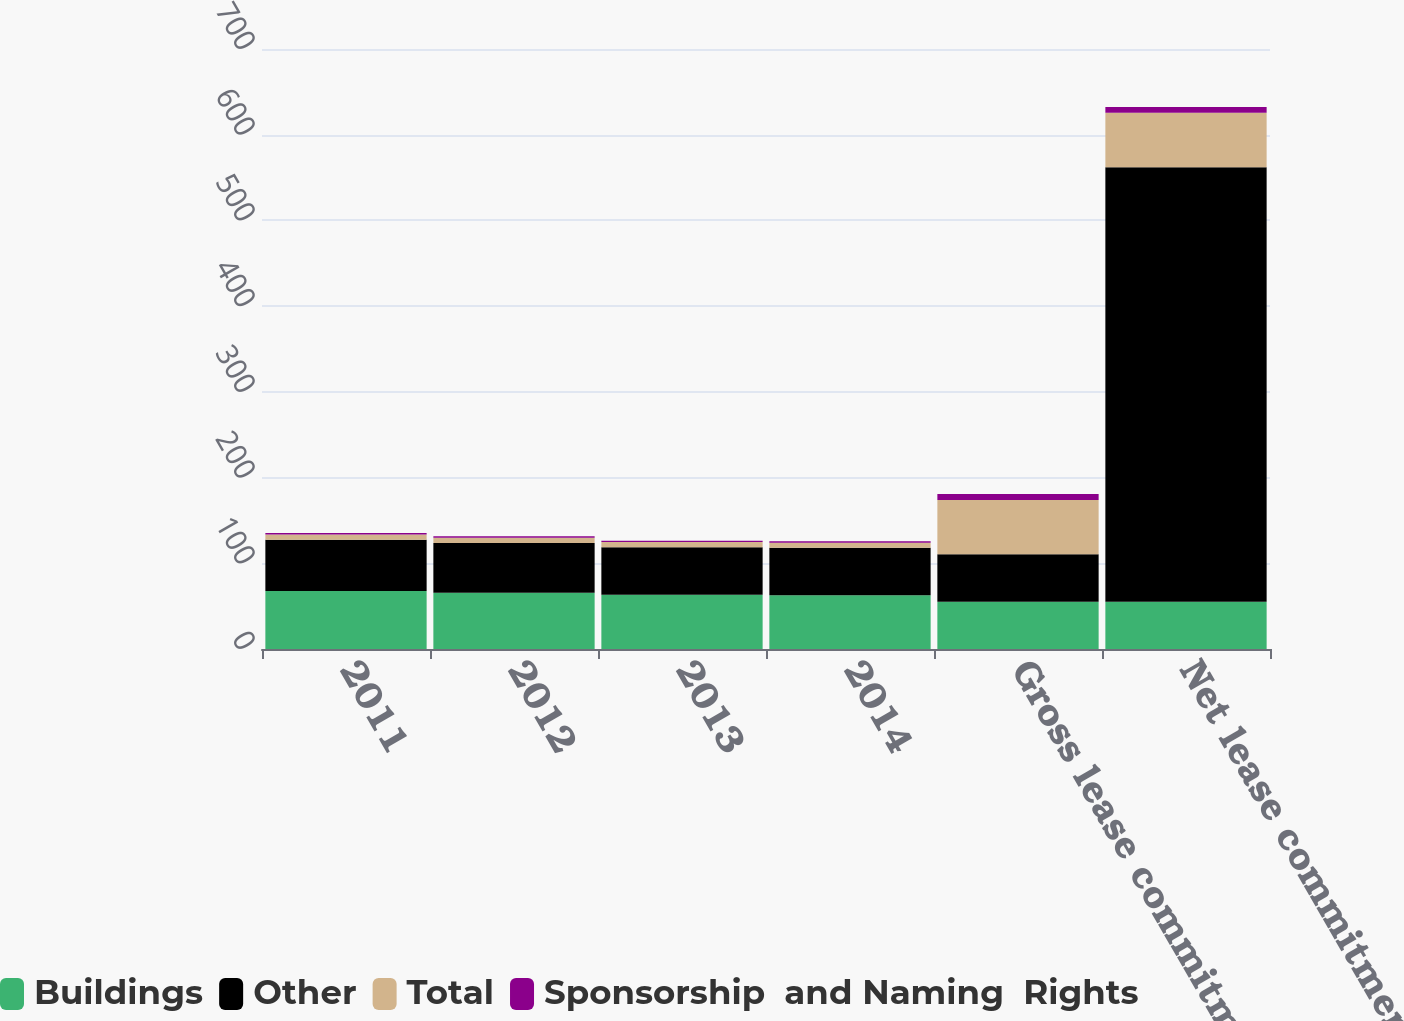Convert chart to OTSL. <chart><loc_0><loc_0><loc_500><loc_500><stacked_bar_chart><ecel><fcel>2011<fcel>2012<fcel>2013<fcel>2014<fcel>Gross lease commitments<fcel>Net lease commitments<nl><fcel>Buildings<fcel>67.7<fcel>65.7<fcel>63.2<fcel>62.8<fcel>55.2<fcel>55.2<nl><fcel>Other<fcel>59.9<fcel>58<fcel>55.5<fcel>55.2<fcel>55.2<fcel>506.9<nl><fcel>Total<fcel>6<fcel>6<fcel>6<fcel>6<fcel>63.5<fcel>63.5<nl><fcel>Sponsorship  and Naming  Rights<fcel>1.8<fcel>1.7<fcel>1.7<fcel>1.6<fcel>6.8<fcel>6.8<nl></chart> 